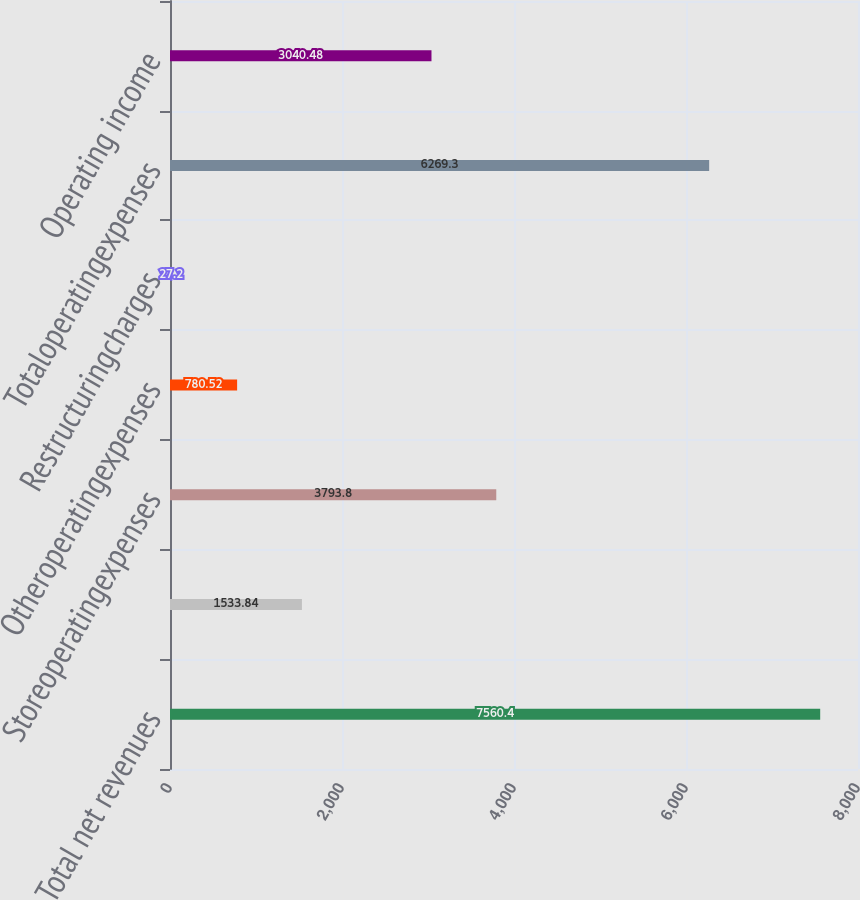Convert chart. <chart><loc_0><loc_0><loc_500><loc_500><bar_chart><fcel>Total net revenues<fcel>Unnamed: 1<fcel>Storeoperatingexpenses<fcel>Otheroperatingexpenses<fcel>Restructuringcharges<fcel>Totaloperatingexpenses<fcel>Operating income<nl><fcel>7560.4<fcel>1533.84<fcel>3793.8<fcel>780.52<fcel>27.2<fcel>6269.3<fcel>3040.48<nl></chart> 